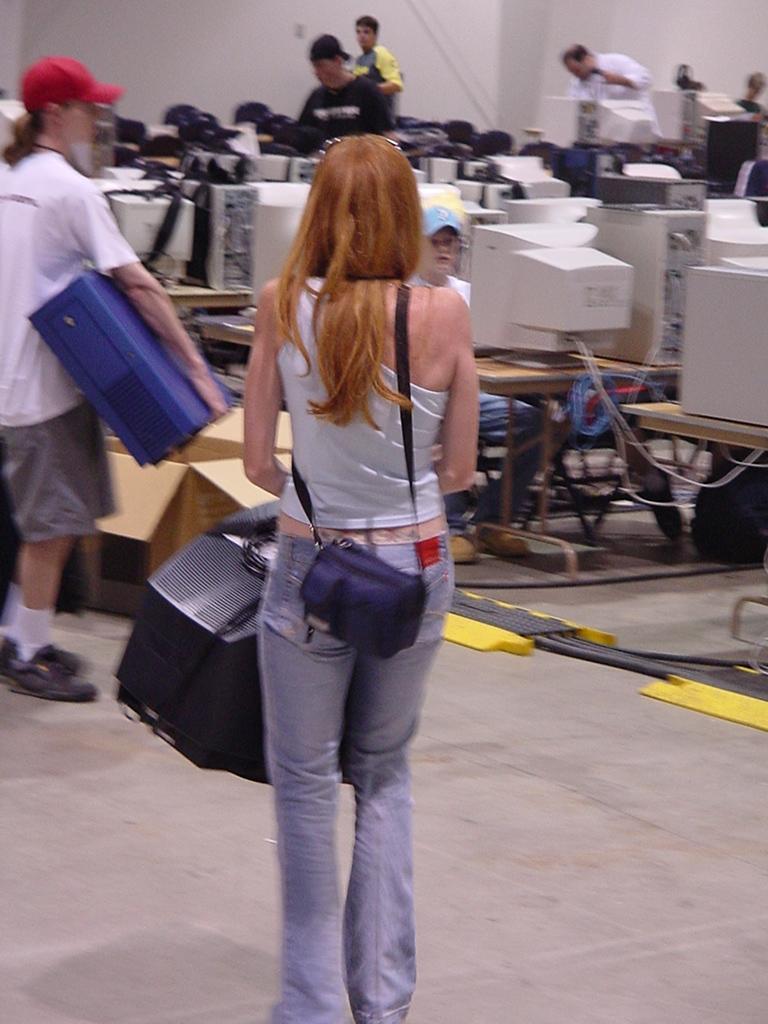How would you summarize this image in a sentence or two? In this image I can see a group of people on the floor, PCs on tables and some objects. In the background I can see a wall. This image is taken, may be in a hall. 